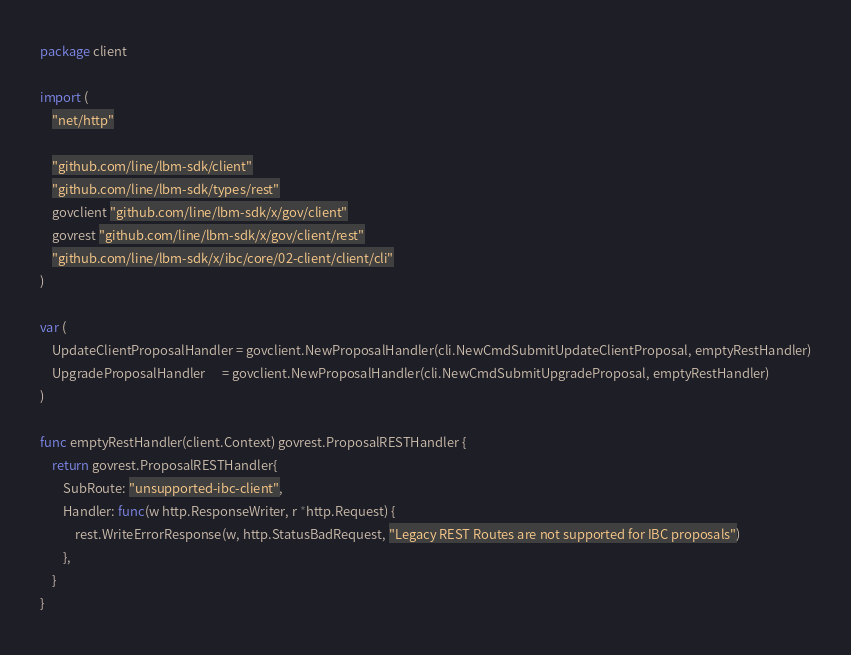Convert code to text. <code><loc_0><loc_0><loc_500><loc_500><_Go_>package client

import (
	"net/http"

	"github.com/line/lbm-sdk/client"
	"github.com/line/lbm-sdk/types/rest"
	govclient "github.com/line/lbm-sdk/x/gov/client"
	govrest "github.com/line/lbm-sdk/x/gov/client/rest"
	"github.com/line/lbm-sdk/x/ibc/core/02-client/client/cli"
)

var (
	UpdateClientProposalHandler = govclient.NewProposalHandler(cli.NewCmdSubmitUpdateClientProposal, emptyRestHandler)
	UpgradeProposalHandler      = govclient.NewProposalHandler(cli.NewCmdSubmitUpgradeProposal, emptyRestHandler)
)

func emptyRestHandler(client.Context) govrest.ProposalRESTHandler {
	return govrest.ProposalRESTHandler{
		SubRoute: "unsupported-ibc-client",
		Handler: func(w http.ResponseWriter, r *http.Request) {
			rest.WriteErrorResponse(w, http.StatusBadRequest, "Legacy REST Routes are not supported for IBC proposals")
		},
	}
}
</code> 